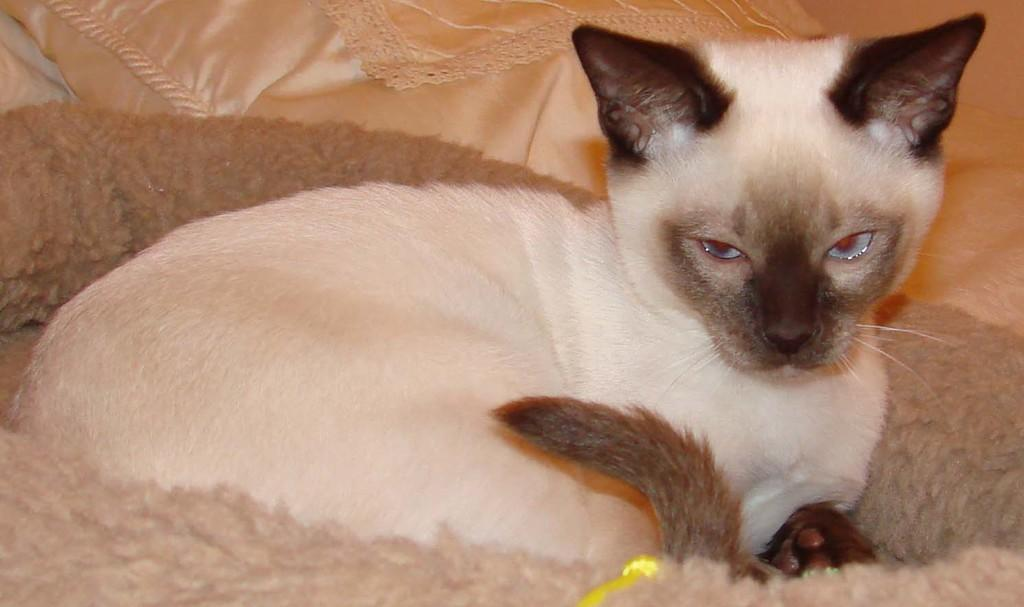What type of animal is in the image? There is a cat in the image. Where is the cat located? The cat is sitting on the bed. What else can be seen on the bed in the image? There is a pillow in the image. What is the rate of the cat's movement in the image? The cat is not moving in the image, so there is no rate of movement to determine. 